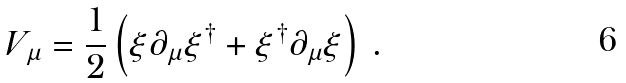Convert formula to latex. <formula><loc_0><loc_0><loc_500><loc_500>V _ { \mu } = \frac { 1 } { 2 } \left ( \xi \partial _ { \mu } \xi ^ { \dagger } + \xi ^ { \dagger } \partial _ { \mu } \xi \right ) \, .</formula> 